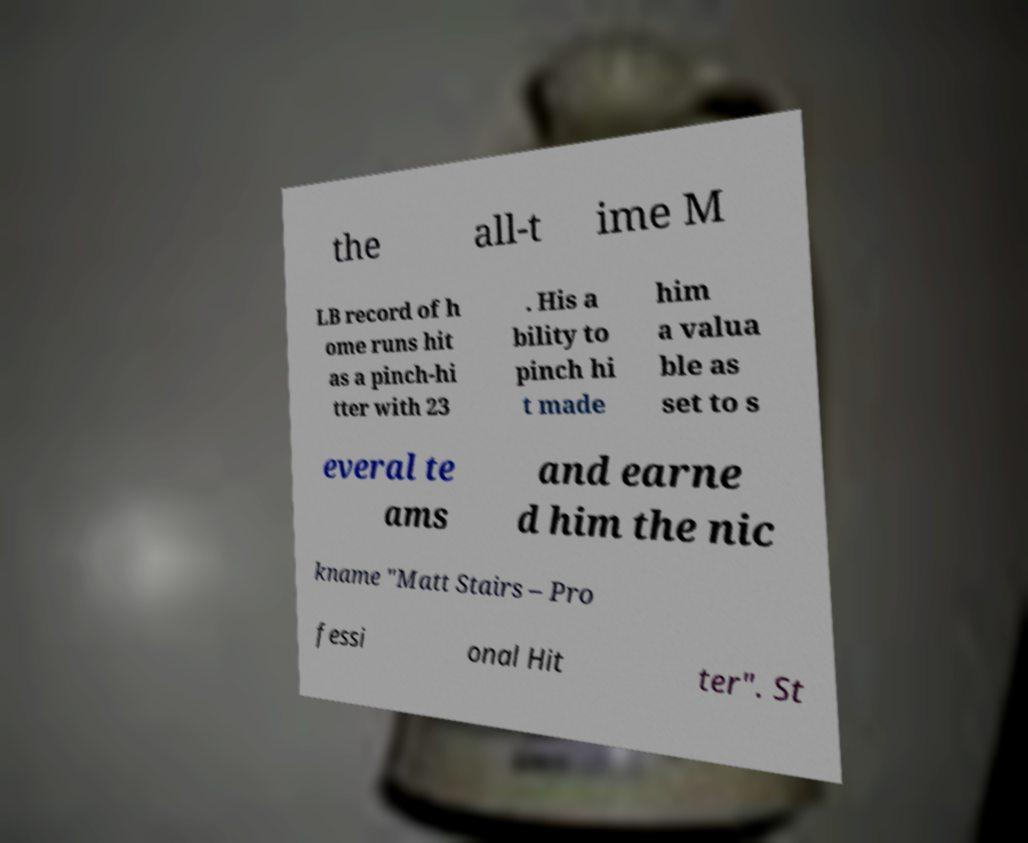Can you accurately transcribe the text from the provided image for me? the all-t ime M LB record of h ome runs hit as a pinch-hi tter with 23 . His a bility to pinch hi t made him a valua ble as set to s everal te ams and earne d him the nic kname "Matt Stairs – Pro fessi onal Hit ter". St 